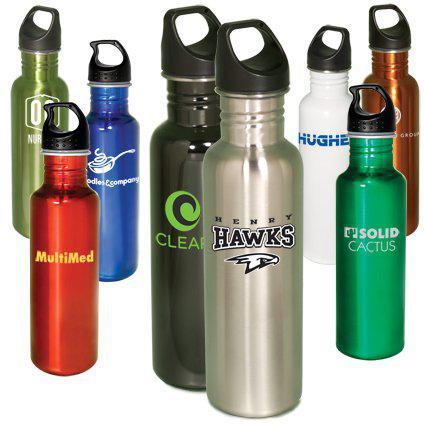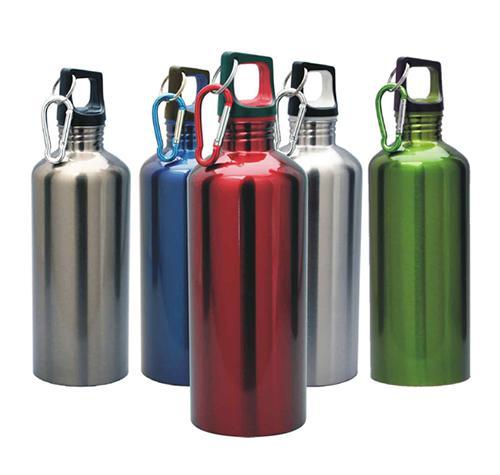The first image is the image on the left, the second image is the image on the right. Analyze the images presented: Is the assertion "At least one of the containers is green in color." valid? Answer yes or no. Yes. The first image is the image on the left, the second image is the image on the right. Analyze the images presented: Is the assertion "The right and left images contain the same number of water bottles." valid? Answer yes or no. No. 